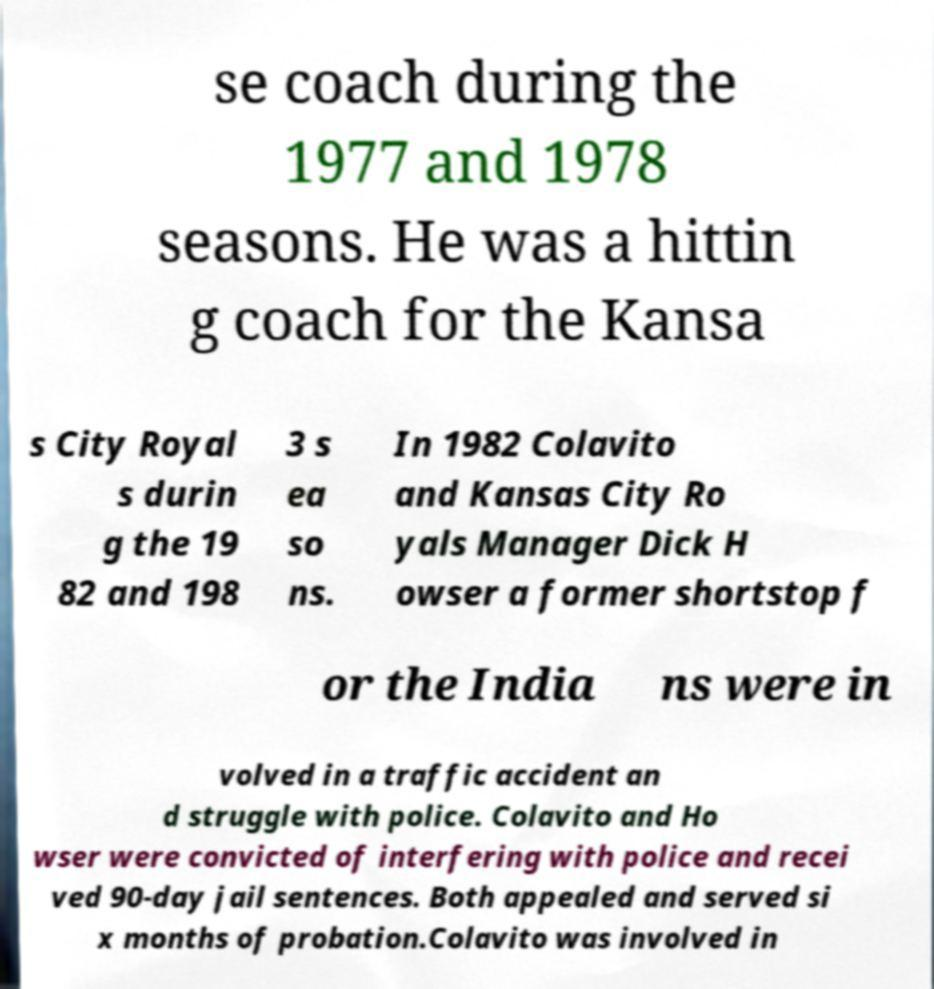What messages or text are displayed in this image? I need them in a readable, typed format. se coach during the 1977 and 1978 seasons. He was a hittin g coach for the Kansa s City Royal s durin g the 19 82 and 198 3 s ea so ns. In 1982 Colavito and Kansas City Ro yals Manager Dick H owser a former shortstop f or the India ns were in volved in a traffic accident an d struggle with police. Colavito and Ho wser were convicted of interfering with police and recei ved 90-day jail sentences. Both appealed and served si x months of probation.Colavito was involved in 